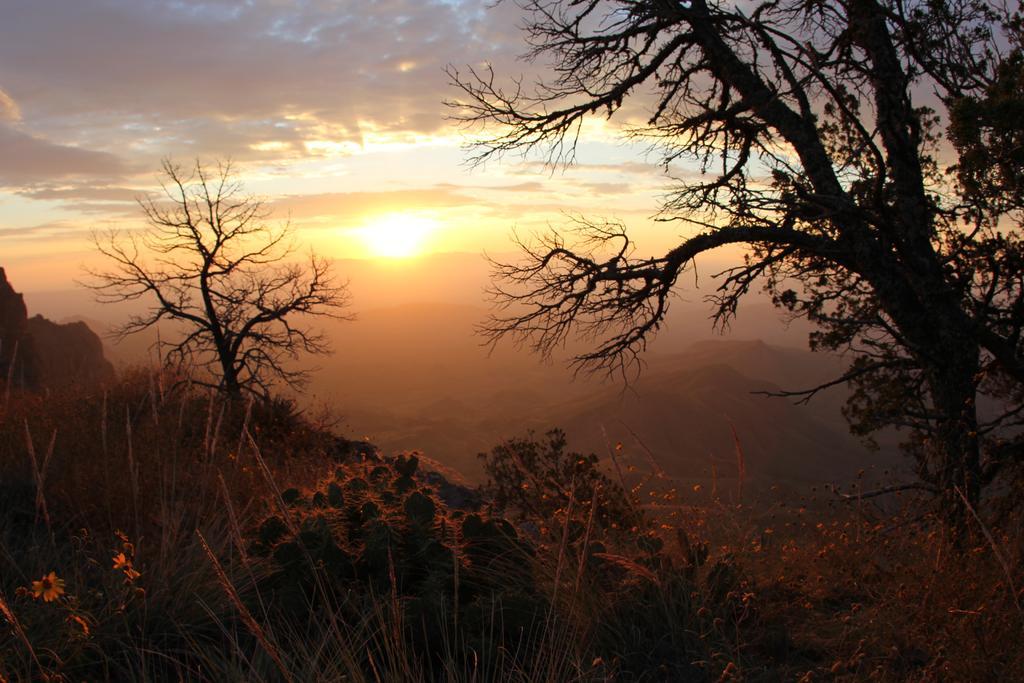Can you describe this image briefly? In this image, we can see some trees and plants. In the middle of the image, we can see the sun in the sky. 